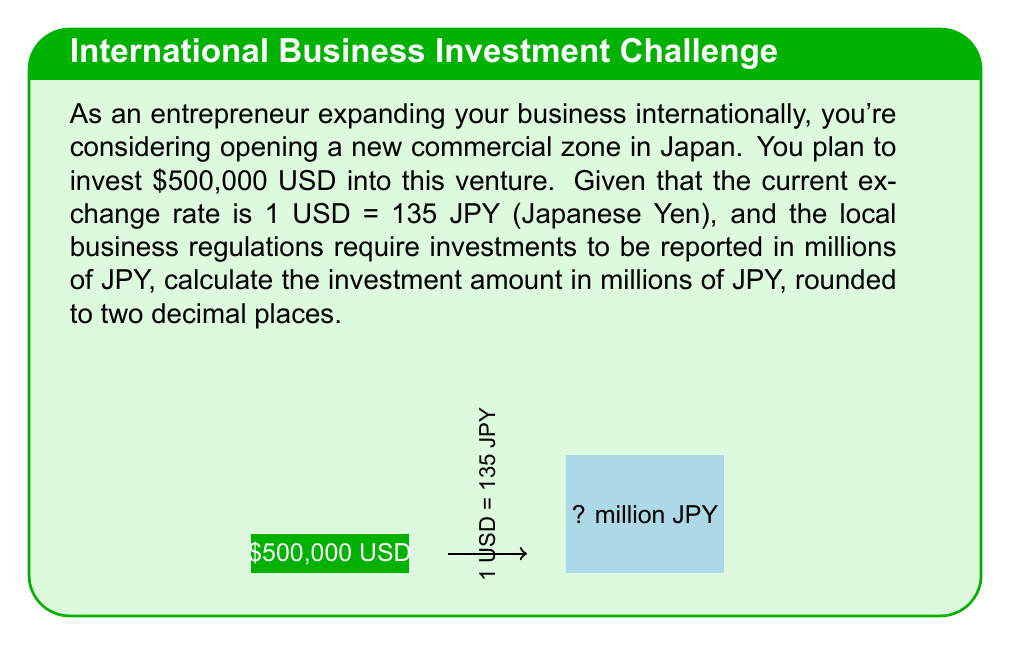Give your solution to this math problem. To solve this problem, we'll follow these steps:

1) First, let's convert the USD amount to JPY:
   $$500,000 \text{ USD} \times 135 \text{ JPY/USD} = 67,500,000 \text{ JPY}$$

2) Now, we need to express this in millions of JPY. To do this, we divide by 1,000,000:
   $$\frac{67,500,000 \text{ JPY}}{1,000,000} = 67.5 \text{ million JPY}$$

3) The question asks for the result rounded to two decimal places. 67.5 is already in this form, so no further rounding is necessary.

Therefore, the investment of $500,000 USD is equivalent to 67.50 million JPY.
Answer: 67.50 million JPY 